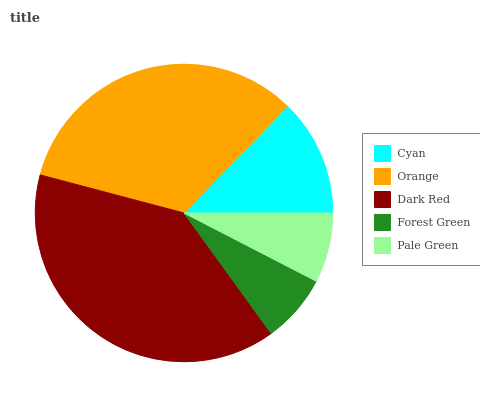Is Forest Green the minimum?
Answer yes or no. Yes. Is Dark Red the maximum?
Answer yes or no. Yes. Is Orange the minimum?
Answer yes or no. No. Is Orange the maximum?
Answer yes or no. No. Is Orange greater than Cyan?
Answer yes or no. Yes. Is Cyan less than Orange?
Answer yes or no. Yes. Is Cyan greater than Orange?
Answer yes or no. No. Is Orange less than Cyan?
Answer yes or no. No. Is Cyan the high median?
Answer yes or no. Yes. Is Cyan the low median?
Answer yes or no. Yes. Is Forest Green the high median?
Answer yes or no. No. Is Pale Green the low median?
Answer yes or no. No. 